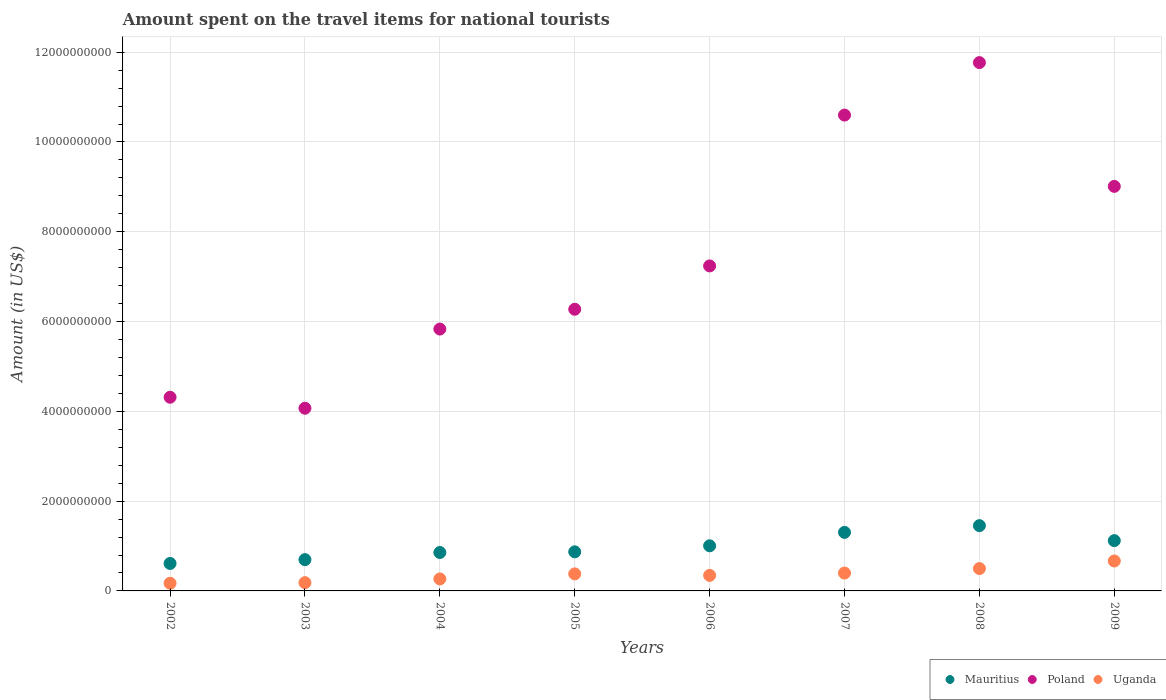How many different coloured dotlines are there?
Offer a very short reply. 3. What is the amount spent on the travel items for national tourists in Uganda in 2004?
Your response must be concise. 2.67e+08. Across all years, what is the maximum amount spent on the travel items for national tourists in Mauritius?
Provide a succinct answer. 1.45e+09. Across all years, what is the minimum amount spent on the travel items for national tourists in Uganda?
Keep it short and to the point. 1.71e+08. In which year was the amount spent on the travel items for national tourists in Poland minimum?
Your response must be concise. 2003. What is the total amount spent on the travel items for national tourists in Mauritius in the graph?
Give a very brief answer. 7.92e+09. What is the difference between the amount spent on the travel items for national tourists in Uganda in 2003 and that in 2006?
Offer a very short reply. -1.62e+08. What is the difference between the amount spent on the travel items for national tourists in Poland in 2007 and the amount spent on the travel items for national tourists in Mauritius in 2008?
Your answer should be very brief. 9.14e+09. What is the average amount spent on the travel items for national tourists in Mauritius per year?
Your answer should be compact. 9.90e+08. In the year 2005, what is the difference between the amount spent on the travel items for national tourists in Uganda and amount spent on the travel items for national tourists in Poland?
Keep it short and to the point. -5.89e+09. In how many years, is the amount spent on the travel items for national tourists in Poland greater than 3200000000 US$?
Give a very brief answer. 8. What is the ratio of the amount spent on the travel items for national tourists in Uganda in 2004 to that in 2007?
Your response must be concise. 0.67. What is the difference between the highest and the second highest amount spent on the travel items for national tourists in Mauritius?
Your answer should be very brief. 1.50e+08. What is the difference between the highest and the lowest amount spent on the travel items for national tourists in Mauritius?
Your answer should be very brief. 8.42e+08. In how many years, is the amount spent on the travel items for national tourists in Poland greater than the average amount spent on the travel items for national tourists in Poland taken over all years?
Your response must be concise. 3. Is the sum of the amount spent on the travel items for national tourists in Mauritius in 2006 and 2007 greater than the maximum amount spent on the travel items for national tourists in Poland across all years?
Your answer should be compact. No. Is it the case that in every year, the sum of the amount spent on the travel items for national tourists in Uganda and amount spent on the travel items for national tourists in Poland  is greater than the amount spent on the travel items for national tourists in Mauritius?
Give a very brief answer. Yes. Is the amount spent on the travel items for national tourists in Poland strictly less than the amount spent on the travel items for national tourists in Uganda over the years?
Ensure brevity in your answer.  No. How many dotlines are there?
Give a very brief answer. 3. How many years are there in the graph?
Make the answer very short. 8. Are the values on the major ticks of Y-axis written in scientific E-notation?
Offer a very short reply. No. Does the graph contain any zero values?
Provide a succinct answer. No. Does the graph contain grids?
Provide a succinct answer. Yes. How many legend labels are there?
Ensure brevity in your answer.  3. How are the legend labels stacked?
Provide a succinct answer. Horizontal. What is the title of the graph?
Your response must be concise. Amount spent on the travel items for national tourists. Does "Panama" appear as one of the legend labels in the graph?
Your answer should be compact. No. What is the label or title of the X-axis?
Ensure brevity in your answer.  Years. What is the label or title of the Y-axis?
Make the answer very short. Amount (in US$). What is the Amount (in US$) in Mauritius in 2002?
Provide a short and direct response. 6.12e+08. What is the Amount (in US$) in Poland in 2002?
Make the answer very short. 4.31e+09. What is the Amount (in US$) of Uganda in 2002?
Your answer should be compact. 1.71e+08. What is the Amount (in US$) of Mauritius in 2003?
Offer a terse response. 6.97e+08. What is the Amount (in US$) of Poland in 2003?
Your response must be concise. 4.07e+09. What is the Amount (in US$) of Uganda in 2003?
Offer a very short reply. 1.84e+08. What is the Amount (in US$) of Mauritius in 2004?
Make the answer very short. 8.56e+08. What is the Amount (in US$) in Poland in 2004?
Offer a very short reply. 5.83e+09. What is the Amount (in US$) in Uganda in 2004?
Offer a very short reply. 2.67e+08. What is the Amount (in US$) in Mauritius in 2005?
Offer a very short reply. 8.71e+08. What is the Amount (in US$) in Poland in 2005?
Your answer should be compact. 6.27e+09. What is the Amount (in US$) in Uganda in 2005?
Ensure brevity in your answer.  3.80e+08. What is the Amount (in US$) of Mauritius in 2006?
Provide a succinct answer. 1.00e+09. What is the Amount (in US$) of Poland in 2006?
Keep it short and to the point. 7.24e+09. What is the Amount (in US$) of Uganda in 2006?
Provide a short and direct response. 3.46e+08. What is the Amount (in US$) of Mauritius in 2007?
Keep it short and to the point. 1.30e+09. What is the Amount (in US$) of Poland in 2007?
Offer a terse response. 1.06e+1. What is the Amount (in US$) of Uganda in 2007?
Give a very brief answer. 3.98e+08. What is the Amount (in US$) of Mauritius in 2008?
Ensure brevity in your answer.  1.45e+09. What is the Amount (in US$) of Poland in 2008?
Provide a short and direct response. 1.18e+1. What is the Amount (in US$) in Uganda in 2008?
Provide a short and direct response. 4.98e+08. What is the Amount (in US$) in Mauritius in 2009?
Your response must be concise. 1.12e+09. What is the Amount (in US$) of Poland in 2009?
Your response must be concise. 9.01e+09. What is the Amount (in US$) in Uganda in 2009?
Your answer should be very brief. 6.67e+08. Across all years, what is the maximum Amount (in US$) of Mauritius?
Provide a succinct answer. 1.45e+09. Across all years, what is the maximum Amount (in US$) in Poland?
Offer a terse response. 1.18e+1. Across all years, what is the maximum Amount (in US$) of Uganda?
Offer a very short reply. 6.67e+08. Across all years, what is the minimum Amount (in US$) of Mauritius?
Offer a very short reply. 6.12e+08. Across all years, what is the minimum Amount (in US$) in Poland?
Keep it short and to the point. 4.07e+09. Across all years, what is the minimum Amount (in US$) of Uganda?
Your response must be concise. 1.71e+08. What is the total Amount (in US$) in Mauritius in the graph?
Provide a succinct answer. 7.92e+09. What is the total Amount (in US$) in Poland in the graph?
Provide a succinct answer. 5.91e+1. What is the total Amount (in US$) of Uganda in the graph?
Ensure brevity in your answer.  2.91e+09. What is the difference between the Amount (in US$) of Mauritius in 2002 and that in 2003?
Make the answer very short. -8.50e+07. What is the difference between the Amount (in US$) in Poland in 2002 and that in 2003?
Make the answer very short. 2.45e+08. What is the difference between the Amount (in US$) in Uganda in 2002 and that in 2003?
Make the answer very short. -1.30e+07. What is the difference between the Amount (in US$) of Mauritius in 2002 and that in 2004?
Provide a short and direct response. -2.44e+08. What is the difference between the Amount (in US$) of Poland in 2002 and that in 2004?
Ensure brevity in your answer.  -1.52e+09. What is the difference between the Amount (in US$) of Uganda in 2002 and that in 2004?
Give a very brief answer. -9.60e+07. What is the difference between the Amount (in US$) in Mauritius in 2002 and that in 2005?
Ensure brevity in your answer.  -2.59e+08. What is the difference between the Amount (in US$) in Poland in 2002 and that in 2005?
Your answer should be very brief. -1.96e+09. What is the difference between the Amount (in US$) in Uganda in 2002 and that in 2005?
Offer a terse response. -2.09e+08. What is the difference between the Amount (in US$) in Mauritius in 2002 and that in 2006?
Your answer should be very brief. -3.93e+08. What is the difference between the Amount (in US$) in Poland in 2002 and that in 2006?
Your answer should be compact. -2.92e+09. What is the difference between the Amount (in US$) in Uganda in 2002 and that in 2006?
Give a very brief answer. -1.75e+08. What is the difference between the Amount (in US$) of Mauritius in 2002 and that in 2007?
Provide a succinct answer. -6.92e+08. What is the difference between the Amount (in US$) of Poland in 2002 and that in 2007?
Offer a terse response. -6.28e+09. What is the difference between the Amount (in US$) of Uganda in 2002 and that in 2007?
Your answer should be compact. -2.27e+08. What is the difference between the Amount (in US$) in Mauritius in 2002 and that in 2008?
Offer a terse response. -8.42e+08. What is the difference between the Amount (in US$) in Poland in 2002 and that in 2008?
Your response must be concise. -7.45e+09. What is the difference between the Amount (in US$) of Uganda in 2002 and that in 2008?
Your response must be concise. -3.27e+08. What is the difference between the Amount (in US$) of Mauritius in 2002 and that in 2009?
Your answer should be compact. -5.08e+08. What is the difference between the Amount (in US$) of Poland in 2002 and that in 2009?
Your answer should be compact. -4.70e+09. What is the difference between the Amount (in US$) of Uganda in 2002 and that in 2009?
Your answer should be very brief. -4.96e+08. What is the difference between the Amount (in US$) in Mauritius in 2003 and that in 2004?
Your answer should be compact. -1.59e+08. What is the difference between the Amount (in US$) of Poland in 2003 and that in 2004?
Give a very brief answer. -1.76e+09. What is the difference between the Amount (in US$) of Uganda in 2003 and that in 2004?
Ensure brevity in your answer.  -8.30e+07. What is the difference between the Amount (in US$) in Mauritius in 2003 and that in 2005?
Give a very brief answer. -1.74e+08. What is the difference between the Amount (in US$) of Poland in 2003 and that in 2005?
Provide a succinct answer. -2.20e+09. What is the difference between the Amount (in US$) in Uganda in 2003 and that in 2005?
Make the answer very short. -1.96e+08. What is the difference between the Amount (in US$) of Mauritius in 2003 and that in 2006?
Give a very brief answer. -3.08e+08. What is the difference between the Amount (in US$) of Poland in 2003 and that in 2006?
Your response must be concise. -3.17e+09. What is the difference between the Amount (in US$) in Uganda in 2003 and that in 2006?
Give a very brief answer. -1.62e+08. What is the difference between the Amount (in US$) of Mauritius in 2003 and that in 2007?
Ensure brevity in your answer.  -6.07e+08. What is the difference between the Amount (in US$) in Poland in 2003 and that in 2007?
Offer a terse response. -6.53e+09. What is the difference between the Amount (in US$) of Uganda in 2003 and that in 2007?
Provide a succinct answer. -2.14e+08. What is the difference between the Amount (in US$) in Mauritius in 2003 and that in 2008?
Offer a terse response. -7.57e+08. What is the difference between the Amount (in US$) of Poland in 2003 and that in 2008?
Offer a terse response. -7.70e+09. What is the difference between the Amount (in US$) of Uganda in 2003 and that in 2008?
Give a very brief answer. -3.14e+08. What is the difference between the Amount (in US$) of Mauritius in 2003 and that in 2009?
Offer a terse response. -4.23e+08. What is the difference between the Amount (in US$) of Poland in 2003 and that in 2009?
Your answer should be compact. -4.94e+09. What is the difference between the Amount (in US$) of Uganda in 2003 and that in 2009?
Make the answer very short. -4.83e+08. What is the difference between the Amount (in US$) of Mauritius in 2004 and that in 2005?
Give a very brief answer. -1.50e+07. What is the difference between the Amount (in US$) of Poland in 2004 and that in 2005?
Give a very brief answer. -4.41e+08. What is the difference between the Amount (in US$) of Uganda in 2004 and that in 2005?
Ensure brevity in your answer.  -1.13e+08. What is the difference between the Amount (in US$) in Mauritius in 2004 and that in 2006?
Give a very brief answer. -1.49e+08. What is the difference between the Amount (in US$) of Poland in 2004 and that in 2006?
Your answer should be compact. -1.41e+09. What is the difference between the Amount (in US$) of Uganda in 2004 and that in 2006?
Give a very brief answer. -7.90e+07. What is the difference between the Amount (in US$) in Mauritius in 2004 and that in 2007?
Keep it short and to the point. -4.48e+08. What is the difference between the Amount (in US$) in Poland in 2004 and that in 2007?
Your answer should be compact. -4.77e+09. What is the difference between the Amount (in US$) of Uganda in 2004 and that in 2007?
Your answer should be compact. -1.31e+08. What is the difference between the Amount (in US$) of Mauritius in 2004 and that in 2008?
Your answer should be very brief. -5.98e+08. What is the difference between the Amount (in US$) of Poland in 2004 and that in 2008?
Make the answer very short. -5.94e+09. What is the difference between the Amount (in US$) in Uganda in 2004 and that in 2008?
Your answer should be compact. -2.31e+08. What is the difference between the Amount (in US$) in Mauritius in 2004 and that in 2009?
Make the answer very short. -2.64e+08. What is the difference between the Amount (in US$) of Poland in 2004 and that in 2009?
Give a very brief answer. -3.18e+09. What is the difference between the Amount (in US$) in Uganda in 2004 and that in 2009?
Make the answer very short. -4.00e+08. What is the difference between the Amount (in US$) in Mauritius in 2005 and that in 2006?
Keep it short and to the point. -1.34e+08. What is the difference between the Amount (in US$) in Poland in 2005 and that in 2006?
Your response must be concise. -9.65e+08. What is the difference between the Amount (in US$) in Uganda in 2005 and that in 2006?
Make the answer very short. 3.40e+07. What is the difference between the Amount (in US$) of Mauritius in 2005 and that in 2007?
Keep it short and to the point. -4.33e+08. What is the difference between the Amount (in US$) of Poland in 2005 and that in 2007?
Keep it short and to the point. -4.32e+09. What is the difference between the Amount (in US$) of Uganda in 2005 and that in 2007?
Offer a terse response. -1.80e+07. What is the difference between the Amount (in US$) in Mauritius in 2005 and that in 2008?
Your answer should be compact. -5.83e+08. What is the difference between the Amount (in US$) in Poland in 2005 and that in 2008?
Your response must be concise. -5.49e+09. What is the difference between the Amount (in US$) in Uganda in 2005 and that in 2008?
Provide a succinct answer. -1.18e+08. What is the difference between the Amount (in US$) of Mauritius in 2005 and that in 2009?
Give a very brief answer. -2.49e+08. What is the difference between the Amount (in US$) of Poland in 2005 and that in 2009?
Offer a very short reply. -2.74e+09. What is the difference between the Amount (in US$) of Uganda in 2005 and that in 2009?
Your response must be concise. -2.87e+08. What is the difference between the Amount (in US$) of Mauritius in 2006 and that in 2007?
Your answer should be compact. -2.99e+08. What is the difference between the Amount (in US$) of Poland in 2006 and that in 2007?
Your answer should be very brief. -3.36e+09. What is the difference between the Amount (in US$) of Uganda in 2006 and that in 2007?
Your answer should be very brief. -5.20e+07. What is the difference between the Amount (in US$) of Mauritius in 2006 and that in 2008?
Ensure brevity in your answer.  -4.49e+08. What is the difference between the Amount (in US$) of Poland in 2006 and that in 2008?
Offer a terse response. -4.53e+09. What is the difference between the Amount (in US$) in Uganda in 2006 and that in 2008?
Ensure brevity in your answer.  -1.52e+08. What is the difference between the Amount (in US$) in Mauritius in 2006 and that in 2009?
Ensure brevity in your answer.  -1.15e+08. What is the difference between the Amount (in US$) in Poland in 2006 and that in 2009?
Your answer should be compact. -1.77e+09. What is the difference between the Amount (in US$) in Uganda in 2006 and that in 2009?
Offer a terse response. -3.21e+08. What is the difference between the Amount (in US$) of Mauritius in 2007 and that in 2008?
Your response must be concise. -1.50e+08. What is the difference between the Amount (in US$) in Poland in 2007 and that in 2008?
Offer a terse response. -1.17e+09. What is the difference between the Amount (in US$) of Uganda in 2007 and that in 2008?
Your answer should be compact. -1.00e+08. What is the difference between the Amount (in US$) of Mauritius in 2007 and that in 2009?
Provide a succinct answer. 1.84e+08. What is the difference between the Amount (in US$) in Poland in 2007 and that in 2009?
Make the answer very short. 1.59e+09. What is the difference between the Amount (in US$) in Uganda in 2007 and that in 2009?
Provide a short and direct response. -2.69e+08. What is the difference between the Amount (in US$) in Mauritius in 2008 and that in 2009?
Give a very brief answer. 3.34e+08. What is the difference between the Amount (in US$) in Poland in 2008 and that in 2009?
Provide a succinct answer. 2.76e+09. What is the difference between the Amount (in US$) in Uganda in 2008 and that in 2009?
Offer a very short reply. -1.69e+08. What is the difference between the Amount (in US$) in Mauritius in 2002 and the Amount (in US$) in Poland in 2003?
Give a very brief answer. -3.46e+09. What is the difference between the Amount (in US$) in Mauritius in 2002 and the Amount (in US$) in Uganda in 2003?
Your answer should be compact. 4.28e+08. What is the difference between the Amount (in US$) in Poland in 2002 and the Amount (in US$) in Uganda in 2003?
Keep it short and to the point. 4.13e+09. What is the difference between the Amount (in US$) in Mauritius in 2002 and the Amount (in US$) in Poland in 2004?
Give a very brief answer. -5.22e+09. What is the difference between the Amount (in US$) in Mauritius in 2002 and the Amount (in US$) in Uganda in 2004?
Provide a short and direct response. 3.45e+08. What is the difference between the Amount (in US$) in Poland in 2002 and the Amount (in US$) in Uganda in 2004?
Your answer should be very brief. 4.05e+09. What is the difference between the Amount (in US$) in Mauritius in 2002 and the Amount (in US$) in Poland in 2005?
Keep it short and to the point. -5.66e+09. What is the difference between the Amount (in US$) in Mauritius in 2002 and the Amount (in US$) in Uganda in 2005?
Your answer should be very brief. 2.32e+08. What is the difference between the Amount (in US$) in Poland in 2002 and the Amount (in US$) in Uganda in 2005?
Your response must be concise. 3.93e+09. What is the difference between the Amount (in US$) in Mauritius in 2002 and the Amount (in US$) in Poland in 2006?
Keep it short and to the point. -6.63e+09. What is the difference between the Amount (in US$) in Mauritius in 2002 and the Amount (in US$) in Uganda in 2006?
Offer a very short reply. 2.66e+08. What is the difference between the Amount (in US$) in Poland in 2002 and the Amount (in US$) in Uganda in 2006?
Make the answer very short. 3.97e+09. What is the difference between the Amount (in US$) in Mauritius in 2002 and the Amount (in US$) in Poland in 2007?
Keep it short and to the point. -9.99e+09. What is the difference between the Amount (in US$) of Mauritius in 2002 and the Amount (in US$) of Uganda in 2007?
Your response must be concise. 2.14e+08. What is the difference between the Amount (in US$) of Poland in 2002 and the Amount (in US$) of Uganda in 2007?
Offer a terse response. 3.92e+09. What is the difference between the Amount (in US$) in Mauritius in 2002 and the Amount (in US$) in Poland in 2008?
Make the answer very short. -1.12e+1. What is the difference between the Amount (in US$) of Mauritius in 2002 and the Amount (in US$) of Uganda in 2008?
Give a very brief answer. 1.14e+08. What is the difference between the Amount (in US$) of Poland in 2002 and the Amount (in US$) of Uganda in 2008?
Make the answer very short. 3.82e+09. What is the difference between the Amount (in US$) in Mauritius in 2002 and the Amount (in US$) in Poland in 2009?
Your answer should be very brief. -8.40e+09. What is the difference between the Amount (in US$) of Mauritius in 2002 and the Amount (in US$) of Uganda in 2009?
Keep it short and to the point. -5.50e+07. What is the difference between the Amount (in US$) in Poland in 2002 and the Amount (in US$) in Uganda in 2009?
Provide a succinct answer. 3.65e+09. What is the difference between the Amount (in US$) of Mauritius in 2003 and the Amount (in US$) of Poland in 2004?
Give a very brief answer. -5.14e+09. What is the difference between the Amount (in US$) in Mauritius in 2003 and the Amount (in US$) in Uganda in 2004?
Your answer should be compact. 4.30e+08. What is the difference between the Amount (in US$) of Poland in 2003 and the Amount (in US$) of Uganda in 2004?
Your answer should be very brief. 3.80e+09. What is the difference between the Amount (in US$) of Mauritius in 2003 and the Amount (in US$) of Poland in 2005?
Ensure brevity in your answer.  -5.58e+09. What is the difference between the Amount (in US$) of Mauritius in 2003 and the Amount (in US$) of Uganda in 2005?
Your answer should be very brief. 3.17e+08. What is the difference between the Amount (in US$) in Poland in 2003 and the Amount (in US$) in Uganda in 2005?
Your answer should be compact. 3.69e+09. What is the difference between the Amount (in US$) of Mauritius in 2003 and the Amount (in US$) of Poland in 2006?
Make the answer very short. -6.54e+09. What is the difference between the Amount (in US$) in Mauritius in 2003 and the Amount (in US$) in Uganda in 2006?
Offer a terse response. 3.51e+08. What is the difference between the Amount (in US$) of Poland in 2003 and the Amount (in US$) of Uganda in 2006?
Provide a succinct answer. 3.72e+09. What is the difference between the Amount (in US$) in Mauritius in 2003 and the Amount (in US$) in Poland in 2007?
Your answer should be compact. -9.90e+09. What is the difference between the Amount (in US$) in Mauritius in 2003 and the Amount (in US$) in Uganda in 2007?
Your answer should be very brief. 2.99e+08. What is the difference between the Amount (in US$) in Poland in 2003 and the Amount (in US$) in Uganda in 2007?
Give a very brief answer. 3.67e+09. What is the difference between the Amount (in US$) of Mauritius in 2003 and the Amount (in US$) of Poland in 2008?
Ensure brevity in your answer.  -1.11e+1. What is the difference between the Amount (in US$) of Mauritius in 2003 and the Amount (in US$) of Uganda in 2008?
Your answer should be compact. 1.99e+08. What is the difference between the Amount (in US$) of Poland in 2003 and the Amount (in US$) of Uganda in 2008?
Ensure brevity in your answer.  3.57e+09. What is the difference between the Amount (in US$) of Mauritius in 2003 and the Amount (in US$) of Poland in 2009?
Ensure brevity in your answer.  -8.31e+09. What is the difference between the Amount (in US$) in Mauritius in 2003 and the Amount (in US$) in Uganda in 2009?
Your answer should be compact. 3.00e+07. What is the difference between the Amount (in US$) in Poland in 2003 and the Amount (in US$) in Uganda in 2009?
Ensure brevity in your answer.  3.40e+09. What is the difference between the Amount (in US$) in Mauritius in 2004 and the Amount (in US$) in Poland in 2005?
Give a very brief answer. -5.42e+09. What is the difference between the Amount (in US$) in Mauritius in 2004 and the Amount (in US$) in Uganda in 2005?
Your response must be concise. 4.76e+08. What is the difference between the Amount (in US$) in Poland in 2004 and the Amount (in US$) in Uganda in 2005?
Offer a very short reply. 5.45e+09. What is the difference between the Amount (in US$) of Mauritius in 2004 and the Amount (in US$) of Poland in 2006?
Give a very brief answer. -6.38e+09. What is the difference between the Amount (in US$) in Mauritius in 2004 and the Amount (in US$) in Uganda in 2006?
Your answer should be very brief. 5.10e+08. What is the difference between the Amount (in US$) in Poland in 2004 and the Amount (in US$) in Uganda in 2006?
Offer a terse response. 5.49e+09. What is the difference between the Amount (in US$) of Mauritius in 2004 and the Amount (in US$) of Poland in 2007?
Ensure brevity in your answer.  -9.74e+09. What is the difference between the Amount (in US$) in Mauritius in 2004 and the Amount (in US$) in Uganda in 2007?
Provide a short and direct response. 4.58e+08. What is the difference between the Amount (in US$) in Poland in 2004 and the Amount (in US$) in Uganda in 2007?
Make the answer very short. 5.44e+09. What is the difference between the Amount (in US$) in Mauritius in 2004 and the Amount (in US$) in Poland in 2008?
Offer a very short reply. -1.09e+1. What is the difference between the Amount (in US$) in Mauritius in 2004 and the Amount (in US$) in Uganda in 2008?
Your answer should be compact. 3.58e+08. What is the difference between the Amount (in US$) of Poland in 2004 and the Amount (in US$) of Uganda in 2008?
Ensure brevity in your answer.  5.34e+09. What is the difference between the Amount (in US$) of Mauritius in 2004 and the Amount (in US$) of Poland in 2009?
Give a very brief answer. -8.16e+09. What is the difference between the Amount (in US$) in Mauritius in 2004 and the Amount (in US$) in Uganda in 2009?
Offer a very short reply. 1.89e+08. What is the difference between the Amount (in US$) in Poland in 2004 and the Amount (in US$) in Uganda in 2009?
Ensure brevity in your answer.  5.17e+09. What is the difference between the Amount (in US$) in Mauritius in 2005 and the Amount (in US$) in Poland in 2006?
Give a very brief answer. -6.37e+09. What is the difference between the Amount (in US$) of Mauritius in 2005 and the Amount (in US$) of Uganda in 2006?
Your answer should be very brief. 5.25e+08. What is the difference between the Amount (in US$) in Poland in 2005 and the Amount (in US$) in Uganda in 2006?
Your answer should be very brief. 5.93e+09. What is the difference between the Amount (in US$) of Mauritius in 2005 and the Amount (in US$) of Poland in 2007?
Provide a succinct answer. -9.73e+09. What is the difference between the Amount (in US$) of Mauritius in 2005 and the Amount (in US$) of Uganda in 2007?
Your answer should be compact. 4.73e+08. What is the difference between the Amount (in US$) of Poland in 2005 and the Amount (in US$) of Uganda in 2007?
Offer a very short reply. 5.88e+09. What is the difference between the Amount (in US$) of Mauritius in 2005 and the Amount (in US$) of Poland in 2008?
Make the answer very short. -1.09e+1. What is the difference between the Amount (in US$) of Mauritius in 2005 and the Amount (in US$) of Uganda in 2008?
Your answer should be very brief. 3.73e+08. What is the difference between the Amount (in US$) of Poland in 2005 and the Amount (in US$) of Uganda in 2008?
Give a very brief answer. 5.78e+09. What is the difference between the Amount (in US$) in Mauritius in 2005 and the Amount (in US$) in Poland in 2009?
Your answer should be very brief. -8.14e+09. What is the difference between the Amount (in US$) in Mauritius in 2005 and the Amount (in US$) in Uganda in 2009?
Keep it short and to the point. 2.04e+08. What is the difference between the Amount (in US$) of Poland in 2005 and the Amount (in US$) of Uganda in 2009?
Ensure brevity in your answer.  5.61e+09. What is the difference between the Amount (in US$) in Mauritius in 2006 and the Amount (in US$) in Poland in 2007?
Keep it short and to the point. -9.59e+09. What is the difference between the Amount (in US$) of Mauritius in 2006 and the Amount (in US$) of Uganda in 2007?
Your answer should be very brief. 6.07e+08. What is the difference between the Amount (in US$) in Poland in 2006 and the Amount (in US$) in Uganda in 2007?
Offer a terse response. 6.84e+09. What is the difference between the Amount (in US$) in Mauritius in 2006 and the Amount (in US$) in Poland in 2008?
Offer a very short reply. -1.08e+1. What is the difference between the Amount (in US$) in Mauritius in 2006 and the Amount (in US$) in Uganda in 2008?
Your response must be concise. 5.07e+08. What is the difference between the Amount (in US$) of Poland in 2006 and the Amount (in US$) of Uganda in 2008?
Offer a terse response. 6.74e+09. What is the difference between the Amount (in US$) of Mauritius in 2006 and the Amount (in US$) of Poland in 2009?
Your answer should be compact. -8.01e+09. What is the difference between the Amount (in US$) in Mauritius in 2006 and the Amount (in US$) in Uganda in 2009?
Keep it short and to the point. 3.38e+08. What is the difference between the Amount (in US$) of Poland in 2006 and the Amount (in US$) of Uganda in 2009?
Offer a very short reply. 6.57e+09. What is the difference between the Amount (in US$) of Mauritius in 2007 and the Amount (in US$) of Poland in 2008?
Your response must be concise. -1.05e+1. What is the difference between the Amount (in US$) in Mauritius in 2007 and the Amount (in US$) in Uganda in 2008?
Offer a terse response. 8.06e+08. What is the difference between the Amount (in US$) in Poland in 2007 and the Amount (in US$) in Uganda in 2008?
Provide a short and direct response. 1.01e+1. What is the difference between the Amount (in US$) of Mauritius in 2007 and the Amount (in US$) of Poland in 2009?
Ensure brevity in your answer.  -7.71e+09. What is the difference between the Amount (in US$) in Mauritius in 2007 and the Amount (in US$) in Uganda in 2009?
Give a very brief answer. 6.37e+08. What is the difference between the Amount (in US$) of Poland in 2007 and the Amount (in US$) of Uganda in 2009?
Your answer should be very brief. 9.93e+09. What is the difference between the Amount (in US$) of Mauritius in 2008 and the Amount (in US$) of Poland in 2009?
Provide a short and direct response. -7.56e+09. What is the difference between the Amount (in US$) of Mauritius in 2008 and the Amount (in US$) of Uganda in 2009?
Provide a short and direct response. 7.87e+08. What is the difference between the Amount (in US$) in Poland in 2008 and the Amount (in US$) in Uganda in 2009?
Give a very brief answer. 1.11e+1. What is the average Amount (in US$) in Mauritius per year?
Ensure brevity in your answer.  9.90e+08. What is the average Amount (in US$) in Poland per year?
Offer a very short reply. 7.39e+09. What is the average Amount (in US$) in Uganda per year?
Provide a succinct answer. 3.64e+08. In the year 2002, what is the difference between the Amount (in US$) in Mauritius and Amount (in US$) in Poland?
Offer a very short reply. -3.70e+09. In the year 2002, what is the difference between the Amount (in US$) in Mauritius and Amount (in US$) in Uganda?
Your answer should be compact. 4.41e+08. In the year 2002, what is the difference between the Amount (in US$) of Poland and Amount (in US$) of Uganda?
Provide a short and direct response. 4.14e+09. In the year 2003, what is the difference between the Amount (in US$) of Mauritius and Amount (in US$) of Poland?
Offer a terse response. -3.37e+09. In the year 2003, what is the difference between the Amount (in US$) in Mauritius and Amount (in US$) in Uganda?
Offer a very short reply. 5.13e+08. In the year 2003, what is the difference between the Amount (in US$) in Poland and Amount (in US$) in Uganda?
Give a very brief answer. 3.88e+09. In the year 2004, what is the difference between the Amount (in US$) of Mauritius and Amount (in US$) of Poland?
Keep it short and to the point. -4.98e+09. In the year 2004, what is the difference between the Amount (in US$) of Mauritius and Amount (in US$) of Uganda?
Give a very brief answer. 5.89e+08. In the year 2004, what is the difference between the Amount (in US$) of Poland and Amount (in US$) of Uganda?
Offer a terse response. 5.57e+09. In the year 2005, what is the difference between the Amount (in US$) in Mauritius and Amount (in US$) in Poland?
Make the answer very short. -5.40e+09. In the year 2005, what is the difference between the Amount (in US$) in Mauritius and Amount (in US$) in Uganda?
Provide a short and direct response. 4.91e+08. In the year 2005, what is the difference between the Amount (in US$) of Poland and Amount (in US$) of Uganda?
Keep it short and to the point. 5.89e+09. In the year 2006, what is the difference between the Amount (in US$) of Mauritius and Amount (in US$) of Poland?
Keep it short and to the point. -6.23e+09. In the year 2006, what is the difference between the Amount (in US$) in Mauritius and Amount (in US$) in Uganda?
Offer a very short reply. 6.59e+08. In the year 2006, what is the difference between the Amount (in US$) in Poland and Amount (in US$) in Uganda?
Your answer should be compact. 6.89e+09. In the year 2007, what is the difference between the Amount (in US$) in Mauritius and Amount (in US$) in Poland?
Provide a succinct answer. -9.30e+09. In the year 2007, what is the difference between the Amount (in US$) of Mauritius and Amount (in US$) of Uganda?
Offer a very short reply. 9.06e+08. In the year 2007, what is the difference between the Amount (in US$) in Poland and Amount (in US$) in Uganda?
Ensure brevity in your answer.  1.02e+1. In the year 2008, what is the difference between the Amount (in US$) in Mauritius and Amount (in US$) in Poland?
Your response must be concise. -1.03e+1. In the year 2008, what is the difference between the Amount (in US$) in Mauritius and Amount (in US$) in Uganda?
Your answer should be compact. 9.56e+08. In the year 2008, what is the difference between the Amount (in US$) of Poland and Amount (in US$) of Uganda?
Your response must be concise. 1.13e+1. In the year 2009, what is the difference between the Amount (in US$) in Mauritius and Amount (in US$) in Poland?
Offer a terse response. -7.89e+09. In the year 2009, what is the difference between the Amount (in US$) in Mauritius and Amount (in US$) in Uganda?
Offer a very short reply. 4.53e+08. In the year 2009, what is the difference between the Amount (in US$) of Poland and Amount (in US$) of Uganda?
Your response must be concise. 8.34e+09. What is the ratio of the Amount (in US$) in Mauritius in 2002 to that in 2003?
Keep it short and to the point. 0.88. What is the ratio of the Amount (in US$) in Poland in 2002 to that in 2003?
Keep it short and to the point. 1.06. What is the ratio of the Amount (in US$) of Uganda in 2002 to that in 2003?
Ensure brevity in your answer.  0.93. What is the ratio of the Amount (in US$) in Mauritius in 2002 to that in 2004?
Make the answer very short. 0.71. What is the ratio of the Amount (in US$) in Poland in 2002 to that in 2004?
Your answer should be compact. 0.74. What is the ratio of the Amount (in US$) of Uganda in 2002 to that in 2004?
Your response must be concise. 0.64. What is the ratio of the Amount (in US$) of Mauritius in 2002 to that in 2005?
Offer a terse response. 0.7. What is the ratio of the Amount (in US$) in Poland in 2002 to that in 2005?
Keep it short and to the point. 0.69. What is the ratio of the Amount (in US$) of Uganda in 2002 to that in 2005?
Offer a terse response. 0.45. What is the ratio of the Amount (in US$) of Mauritius in 2002 to that in 2006?
Ensure brevity in your answer.  0.61. What is the ratio of the Amount (in US$) of Poland in 2002 to that in 2006?
Make the answer very short. 0.6. What is the ratio of the Amount (in US$) in Uganda in 2002 to that in 2006?
Your response must be concise. 0.49. What is the ratio of the Amount (in US$) in Mauritius in 2002 to that in 2007?
Your answer should be very brief. 0.47. What is the ratio of the Amount (in US$) in Poland in 2002 to that in 2007?
Provide a succinct answer. 0.41. What is the ratio of the Amount (in US$) in Uganda in 2002 to that in 2007?
Offer a terse response. 0.43. What is the ratio of the Amount (in US$) in Mauritius in 2002 to that in 2008?
Provide a short and direct response. 0.42. What is the ratio of the Amount (in US$) in Poland in 2002 to that in 2008?
Keep it short and to the point. 0.37. What is the ratio of the Amount (in US$) in Uganda in 2002 to that in 2008?
Your answer should be very brief. 0.34. What is the ratio of the Amount (in US$) in Mauritius in 2002 to that in 2009?
Offer a very short reply. 0.55. What is the ratio of the Amount (in US$) of Poland in 2002 to that in 2009?
Offer a very short reply. 0.48. What is the ratio of the Amount (in US$) of Uganda in 2002 to that in 2009?
Ensure brevity in your answer.  0.26. What is the ratio of the Amount (in US$) in Mauritius in 2003 to that in 2004?
Offer a terse response. 0.81. What is the ratio of the Amount (in US$) in Poland in 2003 to that in 2004?
Offer a very short reply. 0.7. What is the ratio of the Amount (in US$) of Uganda in 2003 to that in 2004?
Give a very brief answer. 0.69. What is the ratio of the Amount (in US$) of Mauritius in 2003 to that in 2005?
Make the answer very short. 0.8. What is the ratio of the Amount (in US$) of Poland in 2003 to that in 2005?
Provide a succinct answer. 0.65. What is the ratio of the Amount (in US$) in Uganda in 2003 to that in 2005?
Keep it short and to the point. 0.48. What is the ratio of the Amount (in US$) in Mauritius in 2003 to that in 2006?
Provide a short and direct response. 0.69. What is the ratio of the Amount (in US$) in Poland in 2003 to that in 2006?
Your response must be concise. 0.56. What is the ratio of the Amount (in US$) of Uganda in 2003 to that in 2006?
Offer a terse response. 0.53. What is the ratio of the Amount (in US$) in Mauritius in 2003 to that in 2007?
Your response must be concise. 0.53. What is the ratio of the Amount (in US$) in Poland in 2003 to that in 2007?
Your answer should be very brief. 0.38. What is the ratio of the Amount (in US$) of Uganda in 2003 to that in 2007?
Give a very brief answer. 0.46. What is the ratio of the Amount (in US$) in Mauritius in 2003 to that in 2008?
Give a very brief answer. 0.48. What is the ratio of the Amount (in US$) of Poland in 2003 to that in 2008?
Make the answer very short. 0.35. What is the ratio of the Amount (in US$) in Uganda in 2003 to that in 2008?
Give a very brief answer. 0.37. What is the ratio of the Amount (in US$) in Mauritius in 2003 to that in 2009?
Offer a terse response. 0.62. What is the ratio of the Amount (in US$) of Poland in 2003 to that in 2009?
Provide a succinct answer. 0.45. What is the ratio of the Amount (in US$) in Uganda in 2003 to that in 2009?
Ensure brevity in your answer.  0.28. What is the ratio of the Amount (in US$) in Mauritius in 2004 to that in 2005?
Offer a terse response. 0.98. What is the ratio of the Amount (in US$) of Poland in 2004 to that in 2005?
Your answer should be compact. 0.93. What is the ratio of the Amount (in US$) in Uganda in 2004 to that in 2005?
Your answer should be very brief. 0.7. What is the ratio of the Amount (in US$) of Mauritius in 2004 to that in 2006?
Keep it short and to the point. 0.85. What is the ratio of the Amount (in US$) of Poland in 2004 to that in 2006?
Ensure brevity in your answer.  0.81. What is the ratio of the Amount (in US$) in Uganda in 2004 to that in 2006?
Make the answer very short. 0.77. What is the ratio of the Amount (in US$) of Mauritius in 2004 to that in 2007?
Your answer should be very brief. 0.66. What is the ratio of the Amount (in US$) in Poland in 2004 to that in 2007?
Offer a terse response. 0.55. What is the ratio of the Amount (in US$) in Uganda in 2004 to that in 2007?
Give a very brief answer. 0.67. What is the ratio of the Amount (in US$) of Mauritius in 2004 to that in 2008?
Your answer should be compact. 0.59. What is the ratio of the Amount (in US$) of Poland in 2004 to that in 2008?
Offer a terse response. 0.5. What is the ratio of the Amount (in US$) of Uganda in 2004 to that in 2008?
Ensure brevity in your answer.  0.54. What is the ratio of the Amount (in US$) of Mauritius in 2004 to that in 2009?
Provide a succinct answer. 0.76. What is the ratio of the Amount (in US$) of Poland in 2004 to that in 2009?
Your response must be concise. 0.65. What is the ratio of the Amount (in US$) in Uganda in 2004 to that in 2009?
Ensure brevity in your answer.  0.4. What is the ratio of the Amount (in US$) of Mauritius in 2005 to that in 2006?
Provide a succinct answer. 0.87. What is the ratio of the Amount (in US$) of Poland in 2005 to that in 2006?
Provide a short and direct response. 0.87. What is the ratio of the Amount (in US$) of Uganda in 2005 to that in 2006?
Offer a terse response. 1.1. What is the ratio of the Amount (in US$) of Mauritius in 2005 to that in 2007?
Your answer should be very brief. 0.67. What is the ratio of the Amount (in US$) in Poland in 2005 to that in 2007?
Your response must be concise. 0.59. What is the ratio of the Amount (in US$) in Uganda in 2005 to that in 2007?
Your response must be concise. 0.95. What is the ratio of the Amount (in US$) of Mauritius in 2005 to that in 2008?
Your response must be concise. 0.6. What is the ratio of the Amount (in US$) in Poland in 2005 to that in 2008?
Your answer should be compact. 0.53. What is the ratio of the Amount (in US$) of Uganda in 2005 to that in 2008?
Provide a short and direct response. 0.76. What is the ratio of the Amount (in US$) of Mauritius in 2005 to that in 2009?
Offer a very short reply. 0.78. What is the ratio of the Amount (in US$) of Poland in 2005 to that in 2009?
Provide a succinct answer. 0.7. What is the ratio of the Amount (in US$) in Uganda in 2005 to that in 2009?
Your response must be concise. 0.57. What is the ratio of the Amount (in US$) of Mauritius in 2006 to that in 2007?
Provide a short and direct response. 0.77. What is the ratio of the Amount (in US$) in Poland in 2006 to that in 2007?
Keep it short and to the point. 0.68. What is the ratio of the Amount (in US$) of Uganda in 2006 to that in 2007?
Provide a succinct answer. 0.87. What is the ratio of the Amount (in US$) of Mauritius in 2006 to that in 2008?
Give a very brief answer. 0.69. What is the ratio of the Amount (in US$) in Poland in 2006 to that in 2008?
Offer a terse response. 0.62. What is the ratio of the Amount (in US$) in Uganda in 2006 to that in 2008?
Ensure brevity in your answer.  0.69. What is the ratio of the Amount (in US$) of Mauritius in 2006 to that in 2009?
Your answer should be compact. 0.9. What is the ratio of the Amount (in US$) in Poland in 2006 to that in 2009?
Your answer should be very brief. 0.8. What is the ratio of the Amount (in US$) of Uganda in 2006 to that in 2009?
Your answer should be very brief. 0.52. What is the ratio of the Amount (in US$) of Mauritius in 2007 to that in 2008?
Offer a very short reply. 0.9. What is the ratio of the Amount (in US$) in Poland in 2007 to that in 2008?
Ensure brevity in your answer.  0.9. What is the ratio of the Amount (in US$) of Uganda in 2007 to that in 2008?
Your answer should be very brief. 0.8. What is the ratio of the Amount (in US$) in Mauritius in 2007 to that in 2009?
Offer a very short reply. 1.16. What is the ratio of the Amount (in US$) of Poland in 2007 to that in 2009?
Provide a short and direct response. 1.18. What is the ratio of the Amount (in US$) of Uganda in 2007 to that in 2009?
Your answer should be compact. 0.6. What is the ratio of the Amount (in US$) in Mauritius in 2008 to that in 2009?
Give a very brief answer. 1.3. What is the ratio of the Amount (in US$) in Poland in 2008 to that in 2009?
Your response must be concise. 1.31. What is the ratio of the Amount (in US$) of Uganda in 2008 to that in 2009?
Make the answer very short. 0.75. What is the difference between the highest and the second highest Amount (in US$) of Mauritius?
Make the answer very short. 1.50e+08. What is the difference between the highest and the second highest Amount (in US$) in Poland?
Your answer should be very brief. 1.17e+09. What is the difference between the highest and the second highest Amount (in US$) in Uganda?
Provide a short and direct response. 1.69e+08. What is the difference between the highest and the lowest Amount (in US$) in Mauritius?
Ensure brevity in your answer.  8.42e+08. What is the difference between the highest and the lowest Amount (in US$) in Poland?
Ensure brevity in your answer.  7.70e+09. What is the difference between the highest and the lowest Amount (in US$) in Uganda?
Offer a very short reply. 4.96e+08. 